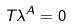<formula> <loc_0><loc_0><loc_500><loc_500>T _ { \L } \lambda ^ { \L A } = 0</formula> 